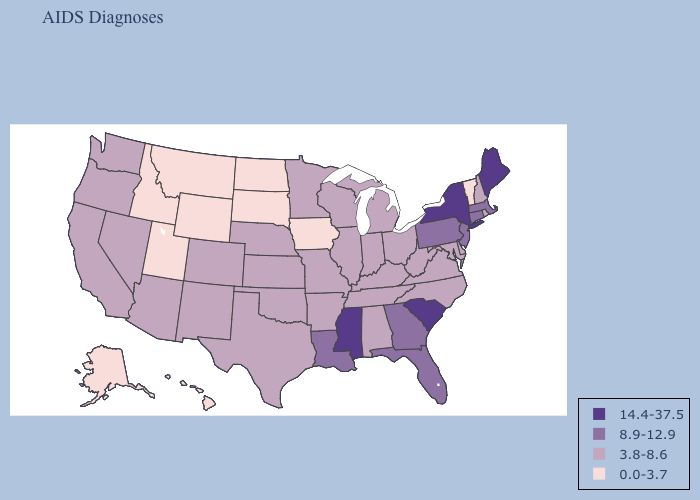Among the states that border Mississippi , which have the lowest value?
Give a very brief answer. Alabama, Arkansas, Tennessee. Among the states that border New York , does Connecticut have the lowest value?
Give a very brief answer. No. Does South Dakota have a higher value than South Carolina?
Keep it brief. No. Does California have the highest value in the West?
Write a very short answer. Yes. What is the highest value in states that border Delaware?
Be succinct. 8.9-12.9. Which states have the lowest value in the USA?
Keep it brief. Alaska, Hawaii, Idaho, Iowa, Montana, North Dakota, South Dakota, Utah, Vermont, Wyoming. What is the value of Massachusetts?
Be succinct. 8.9-12.9. Does the map have missing data?
Concise answer only. No. What is the value of Hawaii?
Keep it brief. 0.0-3.7. Does New York have a higher value than Kentucky?
Keep it brief. Yes. Does the map have missing data?
Keep it brief. No. Among the states that border Washington , does Oregon have the lowest value?
Short answer required. No. What is the lowest value in the USA?
Concise answer only. 0.0-3.7. Which states have the lowest value in the USA?
Write a very short answer. Alaska, Hawaii, Idaho, Iowa, Montana, North Dakota, South Dakota, Utah, Vermont, Wyoming. Does the map have missing data?
Be succinct. No. 